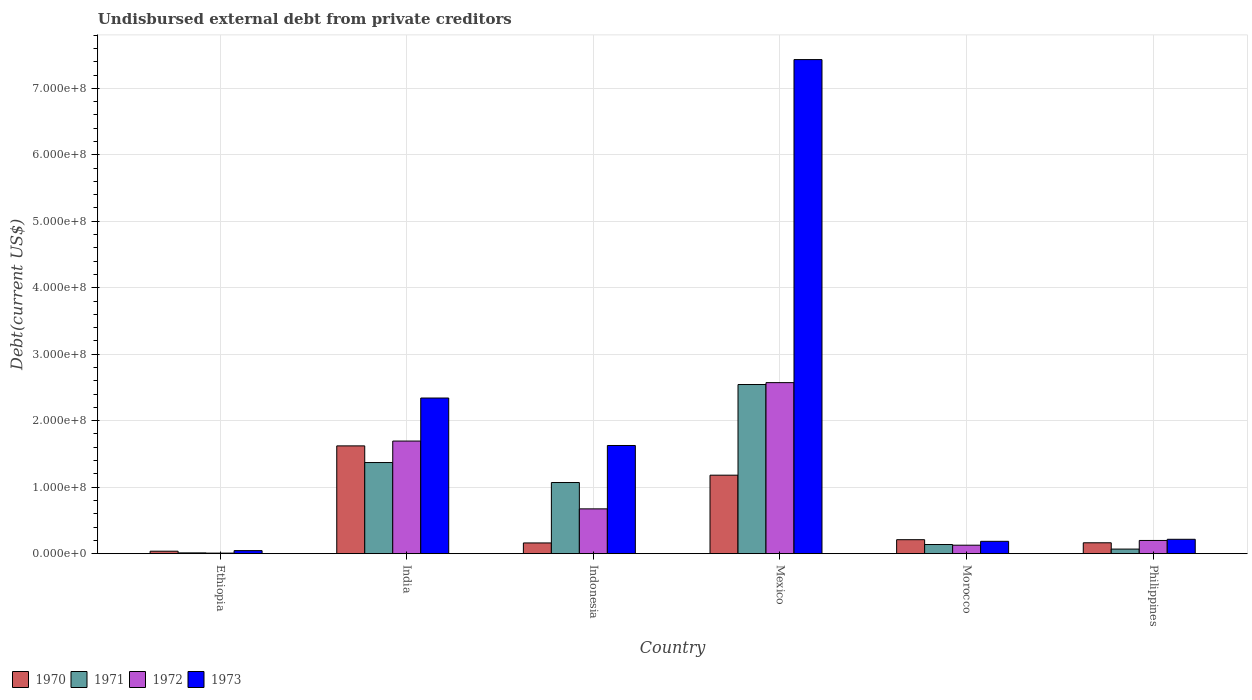How many different coloured bars are there?
Offer a terse response. 4. Are the number of bars per tick equal to the number of legend labels?
Your answer should be very brief. Yes. Are the number of bars on each tick of the X-axis equal?
Your answer should be compact. Yes. How many bars are there on the 2nd tick from the left?
Give a very brief answer. 4. What is the label of the 3rd group of bars from the left?
Keep it short and to the point. Indonesia. What is the total debt in 1972 in Mexico?
Offer a very short reply. 2.57e+08. Across all countries, what is the maximum total debt in 1971?
Offer a terse response. 2.54e+08. Across all countries, what is the minimum total debt in 1971?
Make the answer very short. 1.16e+06. In which country was the total debt in 1973 minimum?
Your response must be concise. Ethiopia. What is the total total debt in 1971 in the graph?
Make the answer very short. 5.20e+08. What is the difference between the total debt in 1973 in Ethiopia and that in Indonesia?
Offer a very short reply. -1.58e+08. What is the difference between the total debt in 1972 in Morocco and the total debt in 1973 in India?
Ensure brevity in your answer.  -2.21e+08. What is the average total debt in 1972 per country?
Provide a short and direct response. 8.79e+07. What is the difference between the total debt of/in 1972 and total debt of/in 1971 in Morocco?
Provide a succinct answer. -1.01e+06. In how many countries, is the total debt in 1972 greater than 420000000 US$?
Provide a short and direct response. 0. What is the ratio of the total debt in 1973 in Indonesia to that in Morocco?
Ensure brevity in your answer.  8.77. Is the total debt in 1970 in Ethiopia less than that in Indonesia?
Ensure brevity in your answer.  Yes. What is the difference between the highest and the second highest total debt in 1971?
Make the answer very short. 1.47e+08. What is the difference between the highest and the lowest total debt in 1971?
Ensure brevity in your answer.  2.53e+08. In how many countries, is the total debt in 1970 greater than the average total debt in 1970 taken over all countries?
Provide a succinct answer. 2. Is the sum of the total debt in 1970 in Ethiopia and India greater than the maximum total debt in 1971 across all countries?
Ensure brevity in your answer.  No. What does the 4th bar from the right in Philippines represents?
Give a very brief answer. 1970. Is it the case that in every country, the sum of the total debt in 1972 and total debt in 1970 is greater than the total debt in 1973?
Offer a terse response. No. Are all the bars in the graph horizontal?
Provide a succinct answer. No. How many countries are there in the graph?
Offer a very short reply. 6. What is the difference between two consecutive major ticks on the Y-axis?
Give a very brief answer. 1.00e+08. Does the graph contain grids?
Keep it short and to the point. Yes. How many legend labels are there?
Make the answer very short. 4. What is the title of the graph?
Your response must be concise. Undisbursed external debt from private creditors. What is the label or title of the Y-axis?
Offer a very short reply. Debt(current US$). What is the Debt(current US$) in 1970 in Ethiopia?
Provide a succinct answer. 3.70e+06. What is the Debt(current US$) in 1971 in Ethiopia?
Your answer should be compact. 1.16e+06. What is the Debt(current US$) in 1972 in Ethiopia?
Your response must be concise. 8.20e+05. What is the Debt(current US$) in 1973 in Ethiopia?
Your response must be concise. 4.57e+06. What is the Debt(current US$) of 1970 in India?
Your answer should be compact. 1.62e+08. What is the Debt(current US$) in 1971 in India?
Offer a terse response. 1.37e+08. What is the Debt(current US$) of 1972 in India?
Your response must be concise. 1.69e+08. What is the Debt(current US$) in 1973 in India?
Your response must be concise. 2.34e+08. What is the Debt(current US$) of 1970 in Indonesia?
Your answer should be very brief. 1.61e+07. What is the Debt(current US$) in 1971 in Indonesia?
Your response must be concise. 1.07e+08. What is the Debt(current US$) in 1972 in Indonesia?
Keep it short and to the point. 6.74e+07. What is the Debt(current US$) of 1973 in Indonesia?
Ensure brevity in your answer.  1.63e+08. What is the Debt(current US$) in 1970 in Mexico?
Give a very brief answer. 1.18e+08. What is the Debt(current US$) in 1971 in Mexico?
Your response must be concise. 2.54e+08. What is the Debt(current US$) in 1972 in Mexico?
Your answer should be very brief. 2.57e+08. What is the Debt(current US$) of 1973 in Mexico?
Provide a short and direct response. 7.43e+08. What is the Debt(current US$) in 1970 in Morocco?
Your answer should be very brief. 2.10e+07. What is the Debt(current US$) in 1971 in Morocco?
Offer a very short reply. 1.37e+07. What is the Debt(current US$) in 1972 in Morocco?
Offer a terse response. 1.27e+07. What is the Debt(current US$) in 1973 in Morocco?
Your response must be concise. 1.86e+07. What is the Debt(current US$) in 1970 in Philippines?
Make the answer very short. 1.64e+07. What is the Debt(current US$) in 1971 in Philippines?
Provide a short and direct response. 6.87e+06. What is the Debt(current US$) of 1972 in Philippines?
Your answer should be very brief. 1.99e+07. What is the Debt(current US$) in 1973 in Philippines?
Provide a short and direct response. 2.16e+07. Across all countries, what is the maximum Debt(current US$) of 1970?
Make the answer very short. 1.62e+08. Across all countries, what is the maximum Debt(current US$) of 1971?
Give a very brief answer. 2.54e+08. Across all countries, what is the maximum Debt(current US$) in 1972?
Your response must be concise. 2.57e+08. Across all countries, what is the maximum Debt(current US$) in 1973?
Offer a terse response. 7.43e+08. Across all countries, what is the minimum Debt(current US$) in 1970?
Your answer should be compact. 3.70e+06. Across all countries, what is the minimum Debt(current US$) in 1971?
Give a very brief answer. 1.16e+06. Across all countries, what is the minimum Debt(current US$) of 1972?
Provide a short and direct response. 8.20e+05. Across all countries, what is the minimum Debt(current US$) of 1973?
Give a very brief answer. 4.57e+06. What is the total Debt(current US$) of 1970 in the graph?
Make the answer very short. 3.37e+08. What is the total Debt(current US$) in 1971 in the graph?
Provide a short and direct response. 5.20e+08. What is the total Debt(current US$) in 1972 in the graph?
Your answer should be very brief. 5.27e+08. What is the total Debt(current US$) in 1973 in the graph?
Offer a terse response. 1.18e+09. What is the difference between the Debt(current US$) in 1970 in Ethiopia and that in India?
Keep it short and to the point. -1.58e+08. What is the difference between the Debt(current US$) of 1971 in Ethiopia and that in India?
Keep it short and to the point. -1.36e+08. What is the difference between the Debt(current US$) in 1972 in Ethiopia and that in India?
Give a very brief answer. -1.69e+08. What is the difference between the Debt(current US$) in 1973 in Ethiopia and that in India?
Make the answer very short. -2.30e+08. What is the difference between the Debt(current US$) of 1970 in Ethiopia and that in Indonesia?
Offer a terse response. -1.24e+07. What is the difference between the Debt(current US$) of 1971 in Ethiopia and that in Indonesia?
Your response must be concise. -1.06e+08. What is the difference between the Debt(current US$) of 1972 in Ethiopia and that in Indonesia?
Provide a succinct answer. -6.66e+07. What is the difference between the Debt(current US$) in 1973 in Ethiopia and that in Indonesia?
Keep it short and to the point. -1.58e+08. What is the difference between the Debt(current US$) in 1970 in Ethiopia and that in Mexico?
Your answer should be very brief. -1.14e+08. What is the difference between the Debt(current US$) of 1971 in Ethiopia and that in Mexico?
Give a very brief answer. -2.53e+08. What is the difference between the Debt(current US$) in 1972 in Ethiopia and that in Mexico?
Ensure brevity in your answer.  -2.56e+08. What is the difference between the Debt(current US$) in 1973 in Ethiopia and that in Mexico?
Your answer should be compact. -7.39e+08. What is the difference between the Debt(current US$) in 1970 in Ethiopia and that in Morocco?
Ensure brevity in your answer.  -1.73e+07. What is the difference between the Debt(current US$) in 1971 in Ethiopia and that in Morocco?
Ensure brevity in your answer.  -1.26e+07. What is the difference between the Debt(current US$) in 1972 in Ethiopia and that in Morocco?
Keep it short and to the point. -1.19e+07. What is the difference between the Debt(current US$) of 1973 in Ethiopia and that in Morocco?
Your answer should be very brief. -1.40e+07. What is the difference between the Debt(current US$) of 1970 in Ethiopia and that in Philippines?
Keep it short and to the point. -1.27e+07. What is the difference between the Debt(current US$) of 1971 in Ethiopia and that in Philippines?
Your answer should be very brief. -5.71e+06. What is the difference between the Debt(current US$) of 1972 in Ethiopia and that in Philippines?
Offer a terse response. -1.90e+07. What is the difference between the Debt(current US$) of 1973 in Ethiopia and that in Philippines?
Give a very brief answer. -1.71e+07. What is the difference between the Debt(current US$) of 1970 in India and that in Indonesia?
Offer a very short reply. 1.46e+08. What is the difference between the Debt(current US$) of 1971 in India and that in Indonesia?
Provide a short and direct response. 3.00e+07. What is the difference between the Debt(current US$) of 1972 in India and that in Indonesia?
Keep it short and to the point. 1.02e+08. What is the difference between the Debt(current US$) in 1973 in India and that in Indonesia?
Make the answer very short. 7.14e+07. What is the difference between the Debt(current US$) of 1970 in India and that in Mexico?
Keep it short and to the point. 4.41e+07. What is the difference between the Debt(current US$) in 1971 in India and that in Mexico?
Offer a very short reply. -1.17e+08. What is the difference between the Debt(current US$) of 1972 in India and that in Mexico?
Keep it short and to the point. -8.79e+07. What is the difference between the Debt(current US$) in 1973 in India and that in Mexico?
Your response must be concise. -5.09e+08. What is the difference between the Debt(current US$) in 1970 in India and that in Morocco?
Provide a short and direct response. 1.41e+08. What is the difference between the Debt(current US$) of 1971 in India and that in Morocco?
Give a very brief answer. 1.23e+08. What is the difference between the Debt(current US$) in 1972 in India and that in Morocco?
Your response must be concise. 1.57e+08. What is the difference between the Debt(current US$) in 1973 in India and that in Morocco?
Ensure brevity in your answer.  2.16e+08. What is the difference between the Debt(current US$) of 1970 in India and that in Philippines?
Keep it short and to the point. 1.46e+08. What is the difference between the Debt(current US$) of 1971 in India and that in Philippines?
Your response must be concise. 1.30e+08. What is the difference between the Debt(current US$) in 1972 in India and that in Philippines?
Ensure brevity in your answer.  1.50e+08. What is the difference between the Debt(current US$) in 1973 in India and that in Philippines?
Ensure brevity in your answer.  2.12e+08. What is the difference between the Debt(current US$) in 1970 in Indonesia and that in Mexico?
Offer a terse response. -1.02e+08. What is the difference between the Debt(current US$) in 1971 in Indonesia and that in Mexico?
Give a very brief answer. -1.47e+08. What is the difference between the Debt(current US$) of 1972 in Indonesia and that in Mexico?
Provide a succinct answer. -1.90e+08. What is the difference between the Debt(current US$) in 1973 in Indonesia and that in Mexico?
Provide a succinct answer. -5.81e+08. What is the difference between the Debt(current US$) in 1970 in Indonesia and that in Morocco?
Provide a short and direct response. -4.89e+06. What is the difference between the Debt(current US$) of 1971 in Indonesia and that in Morocco?
Keep it short and to the point. 9.33e+07. What is the difference between the Debt(current US$) of 1972 in Indonesia and that in Morocco?
Offer a terse response. 5.46e+07. What is the difference between the Debt(current US$) in 1973 in Indonesia and that in Morocco?
Your answer should be very brief. 1.44e+08. What is the difference between the Debt(current US$) of 1970 in Indonesia and that in Philippines?
Keep it short and to the point. -2.28e+05. What is the difference between the Debt(current US$) of 1971 in Indonesia and that in Philippines?
Keep it short and to the point. 1.00e+08. What is the difference between the Debt(current US$) of 1972 in Indonesia and that in Philippines?
Your answer should be compact. 4.75e+07. What is the difference between the Debt(current US$) of 1973 in Indonesia and that in Philippines?
Keep it short and to the point. 1.41e+08. What is the difference between the Debt(current US$) in 1970 in Mexico and that in Morocco?
Make the answer very short. 9.70e+07. What is the difference between the Debt(current US$) of 1971 in Mexico and that in Morocco?
Make the answer very short. 2.41e+08. What is the difference between the Debt(current US$) in 1972 in Mexico and that in Morocco?
Make the answer very short. 2.45e+08. What is the difference between the Debt(current US$) in 1973 in Mexico and that in Morocco?
Your response must be concise. 7.25e+08. What is the difference between the Debt(current US$) of 1970 in Mexico and that in Philippines?
Offer a terse response. 1.02e+08. What is the difference between the Debt(current US$) in 1971 in Mexico and that in Philippines?
Give a very brief answer. 2.48e+08. What is the difference between the Debt(current US$) of 1972 in Mexico and that in Philippines?
Keep it short and to the point. 2.37e+08. What is the difference between the Debt(current US$) of 1973 in Mexico and that in Philippines?
Make the answer very short. 7.22e+08. What is the difference between the Debt(current US$) in 1970 in Morocco and that in Philippines?
Keep it short and to the point. 4.66e+06. What is the difference between the Debt(current US$) in 1971 in Morocco and that in Philippines?
Make the answer very short. 6.88e+06. What is the difference between the Debt(current US$) in 1972 in Morocco and that in Philippines?
Give a very brief answer. -7.12e+06. What is the difference between the Debt(current US$) in 1973 in Morocco and that in Philippines?
Your answer should be very brief. -3.06e+06. What is the difference between the Debt(current US$) of 1970 in Ethiopia and the Debt(current US$) of 1971 in India?
Give a very brief answer. -1.33e+08. What is the difference between the Debt(current US$) in 1970 in Ethiopia and the Debt(current US$) in 1972 in India?
Give a very brief answer. -1.66e+08. What is the difference between the Debt(current US$) in 1970 in Ethiopia and the Debt(current US$) in 1973 in India?
Offer a very short reply. -2.30e+08. What is the difference between the Debt(current US$) of 1971 in Ethiopia and the Debt(current US$) of 1972 in India?
Ensure brevity in your answer.  -1.68e+08. What is the difference between the Debt(current US$) of 1971 in Ethiopia and the Debt(current US$) of 1973 in India?
Give a very brief answer. -2.33e+08. What is the difference between the Debt(current US$) of 1972 in Ethiopia and the Debt(current US$) of 1973 in India?
Your answer should be very brief. -2.33e+08. What is the difference between the Debt(current US$) of 1970 in Ethiopia and the Debt(current US$) of 1971 in Indonesia?
Offer a very short reply. -1.03e+08. What is the difference between the Debt(current US$) in 1970 in Ethiopia and the Debt(current US$) in 1972 in Indonesia?
Your answer should be compact. -6.37e+07. What is the difference between the Debt(current US$) of 1970 in Ethiopia and the Debt(current US$) of 1973 in Indonesia?
Give a very brief answer. -1.59e+08. What is the difference between the Debt(current US$) in 1971 in Ethiopia and the Debt(current US$) in 1972 in Indonesia?
Make the answer very short. -6.62e+07. What is the difference between the Debt(current US$) of 1971 in Ethiopia and the Debt(current US$) of 1973 in Indonesia?
Keep it short and to the point. -1.62e+08. What is the difference between the Debt(current US$) in 1972 in Ethiopia and the Debt(current US$) in 1973 in Indonesia?
Make the answer very short. -1.62e+08. What is the difference between the Debt(current US$) in 1970 in Ethiopia and the Debt(current US$) in 1971 in Mexico?
Ensure brevity in your answer.  -2.51e+08. What is the difference between the Debt(current US$) in 1970 in Ethiopia and the Debt(current US$) in 1972 in Mexico?
Give a very brief answer. -2.54e+08. What is the difference between the Debt(current US$) in 1970 in Ethiopia and the Debt(current US$) in 1973 in Mexico?
Provide a short and direct response. -7.40e+08. What is the difference between the Debt(current US$) in 1971 in Ethiopia and the Debt(current US$) in 1972 in Mexico?
Provide a short and direct response. -2.56e+08. What is the difference between the Debt(current US$) of 1971 in Ethiopia and the Debt(current US$) of 1973 in Mexico?
Your answer should be very brief. -7.42e+08. What is the difference between the Debt(current US$) of 1972 in Ethiopia and the Debt(current US$) of 1973 in Mexico?
Your answer should be very brief. -7.42e+08. What is the difference between the Debt(current US$) in 1970 in Ethiopia and the Debt(current US$) in 1971 in Morocco?
Provide a succinct answer. -1.01e+07. What is the difference between the Debt(current US$) in 1970 in Ethiopia and the Debt(current US$) in 1972 in Morocco?
Your response must be concise. -9.04e+06. What is the difference between the Debt(current US$) of 1970 in Ethiopia and the Debt(current US$) of 1973 in Morocco?
Offer a very short reply. -1.49e+07. What is the difference between the Debt(current US$) in 1971 in Ethiopia and the Debt(current US$) in 1972 in Morocco?
Your answer should be very brief. -1.16e+07. What is the difference between the Debt(current US$) of 1971 in Ethiopia and the Debt(current US$) of 1973 in Morocco?
Make the answer very short. -1.74e+07. What is the difference between the Debt(current US$) of 1972 in Ethiopia and the Debt(current US$) of 1973 in Morocco?
Offer a very short reply. -1.77e+07. What is the difference between the Debt(current US$) of 1970 in Ethiopia and the Debt(current US$) of 1971 in Philippines?
Offer a terse response. -3.18e+06. What is the difference between the Debt(current US$) in 1970 in Ethiopia and the Debt(current US$) in 1972 in Philippines?
Offer a terse response. -1.62e+07. What is the difference between the Debt(current US$) of 1970 in Ethiopia and the Debt(current US$) of 1973 in Philippines?
Keep it short and to the point. -1.79e+07. What is the difference between the Debt(current US$) in 1971 in Ethiopia and the Debt(current US$) in 1972 in Philippines?
Your answer should be compact. -1.87e+07. What is the difference between the Debt(current US$) of 1971 in Ethiopia and the Debt(current US$) of 1973 in Philippines?
Your response must be concise. -2.05e+07. What is the difference between the Debt(current US$) of 1972 in Ethiopia and the Debt(current US$) of 1973 in Philippines?
Give a very brief answer. -2.08e+07. What is the difference between the Debt(current US$) of 1970 in India and the Debt(current US$) of 1971 in Indonesia?
Provide a short and direct response. 5.51e+07. What is the difference between the Debt(current US$) of 1970 in India and the Debt(current US$) of 1972 in Indonesia?
Ensure brevity in your answer.  9.47e+07. What is the difference between the Debt(current US$) in 1970 in India and the Debt(current US$) in 1973 in Indonesia?
Your answer should be compact. -5.84e+05. What is the difference between the Debt(current US$) of 1971 in India and the Debt(current US$) of 1972 in Indonesia?
Offer a very short reply. 6.97e+07. What is the difference between the Debt(current US$) of 1971 in India and the Debt(current US$) of 1973 in Indonesia?
Keep it short and to the point. -2.56e+07. What is the difference between the Debt(current US$) of 1972 in India and the Debt(current US$) of 1973 in Indonesia?
Make the answer very short. 6.68e+06. What is the difference between the Debt(current US$) of 1970 in India and the Debt(current US$) of 1971 in Mexico?
Offer a terse response. -9.23e+07. What is the difference between the Debt(current US$) in 1970 in India and the Debt(current US$) in 1972 in Mexico?
Offer a terse response. -9.51e+07. What is the difference between the Debt(current US$) of 1970 in India and the Debt(current US$) of 1973 in Mexico?
Provide a succinct answer. -5.81e+08. What is the difference between the Debt(current US$) in 1971 in India and the Debt(current US$) in 1972 in Mexico?
Offer a very short reply. -1.20e+08. What is the difference between the Debt(current US$) in 1971 in India and the Debt(current US$) in 1973 in Mexico?
Your answer should be compact. -6.06e+08. What is the difference between the Debt(current US$) of 1972 in India and the Debt(current US$) of 1973 in Mexico?
Keep it short and to the point. -5.74e+08. What is the difference between the Debt(current US$) of 1970 in India and the Debt(current US$) of 1971 in Morocco?
Give a very brief answer. 1.48e+08. What is the difference between the Debt(current US$) of 1970 in India and the Debt(current US$) of 1972 in Morocco?
Offer a very short reply. 1.49e+08. What is the difference between the Debt(current US$) in 1970 in India and the Debt(current US$) in 1973 in Morocco?
Provide a short and direct response. 1.44e+08. What is the difference between the Debt(current US$) of 1971 in India and the Debt(current US$) of 1972 in Morocco?
Ensure brevity in your answer.  1.24e+08. What is the difference between the Debt(current US$) of 1971 in India and the Debt(current US$) of 1973 in Morocco?
Offer a very short reply. 1.19e+08. What is the difference between the Debt(current US$) in 1972 in India and the Debt(current US$) in 1973 in Morocco?
Offer a terse response. 1.51e+08. What is the difference between the Debt(current US$) in 1970 in India and the Debt(current US$) in 1971 in Philippines?
Your answer should be very brief. 1.55e+08. What is the difference between the Debt(current US$) of 1970 in India and the Debt(current US$) of 1972 in Philippines?
Ensure brevity in your answer.  1.42e+08. What is the difference between the Debt(current US$) of 1970 in India and the Debt(current US$) of 1973 in Philippines?
Make the answer very short. 1.41e+08. What is the difference between the Debt(current US$) in 1971 in India and the Debt(current US$) in 1972 in Philippines?
Offer a very short reply. 1.17e+08. What is the difference between the Debt(current US$) in 1971 in India and the Debt(current US$) in 1973 in Philippines?
Your answer should be very brief. 1.15e+08. What is the difference between the Debt(current US$) in 1972 in India and the Debt(current US$) in 1973 in Philippines?
Your response must be concise. 1.48e+08. What is the difference between the Debt(current US$) in 1970 in Indonesia and the Debt(current US$) in 1971 in Mexico?
Make the answer very short. -2.38e+08. What is the difference between the Debt(current US$) in 1970 in Indonesia and the Debt(current US$) in 1972 in Mexico?
Make the answer very short. -2.41e+08. What is the difference between the Debt(current US$) of 1970 in Indonesia and the Debt(current US$) of 1973 in Mexico?
Your response must be concise. -7.27e+08. What is the difference between the Debt(current US$) in 1971 in Indonesia and the Debt(current US$) in 1972 in Mexico?
Provide a succinct answer. -1.50e+08. What is the difference between the Debt(current US$) in 1971 in Indonesia and the Debt(current US$) in 1973 in Mexico?
Your answer should be very brief. -6.36e+08. What is the difference between the Debt(current US$) of 1972 in Indonesia and the Debt(current US$) of 1973 in Mexico?
Provide a succinct answer. -6.76e+08. What is the difference between the Debt(current US$) in 1970 in Indonesia and the Debt(current US$) in 1971 in Morocco?
Your answer should be very brief. 2.38e+06. What is the difference between the Debt(current US$) in 1970 in Indonesia and the Debt(current US$) in 1972 in Morocco?
Offer a terse response. 3.39e+06. What is the difference between the Debt(current US$) in 1970 in Indonesia and the Debt(current US$) in 1973 in Morocco?
Ensure brevity in your answer.  -2.44e+06. What is the difference between the Debt(current US$) of 1971 in Indonesia and the Debt(current US$) of 1972 in Morocco?
Give a very brief answer. 9.43e+07. What is the difference between the Debt(current US$) in 1971 in Indonesia and the Debt(current US$) in 1973 in Morocco?
Provide a succinct answer. 8.85e+07. What is the difference between the Debt(current US$) of 1972 in Indonesia and the Debt(current US$) of 1973 in Morocco?
Provide a short and direct response. 4.88e+07. What is the difference between the Debt(current US$) of 1970 in Indonesia and the Debt(current US$) of 1971 in Philippines?
Provide a succinct answer. 9.25e+06. What is the difference between the Debt(current US$) in 1970 in Indonesia and the Debt(current US$) in 1972 in Philippines?
Offer a very short reply. -3.73e+06. What is the difference between the Debt(current US$) in 1970 in Indonesia and the Debt(current US$) in 1973 in Philippines?
Your answer should be very brief. -5.49e+06. What is the difference between the Debt(current US$) of 1971 in Indonesia and the Debt(current US$) of 1972 in Philippines?
Provide a succinct answer. 8.72e+07. What is the difference between the Debt(current US$) of 1971 in Indonesia and the Debt(current US$) of 1973 in Philippines?
Your answer should be compact. 8.54e+07. What is the difference between the Debt(current US$) in 1972 in Indonesia and the Debt(current US$) in 1973 in Philippines?
Your answer should be very brief. 4.58e+07. What is the difference between the Debt(current US$) in 1970 in Mexico and the Debt(current US$) in 1971 in Morocco?
Your answer should be very brief. 1.04e+08. What is the difference between the Debt(current US$) in 1970 in Mexico and the Debt(current US$) in 1972 in Morocco?
Your response must be concise. 1.05e+08. What is the difference between the Debt(current US$) in 1970 in Mexico and the Debt(current US$) in 1973 in Morocco?
Provide a short and direct response. 9.95e+07. What is the difference between the Debt(current US$) in 1971 in Mexico and the Debt(current US$) in 1972 in Morocco?
Make the answer very short. 2.42e+08. What is the difference between the Debt(current US$) in 1971 in Mexico and the Debt(current US$) in 1973 in Morocco?
Give a very brief answer. 2.36e+08. What is the difference between the Debt(current US$) in 1972 in Mexico and the Debt(current US$) in 1973 in Morocco?
Your response must be concise. 2.39e+08. What is the difference between the Debt(current US$) of 1970 in Mexico and the Debt(current US$) of 1971 in Philippines?
Your response must be concise. 1.11e+08. What is the difference between the Debt(current US$) in 1970 in Mexico and the Debt(current US$) in 1972 in Philippines?
Keep it short and to the point. 9.82e+07. What is the difference between the Debt(current US$) in 1970 in Mexico and the Debt(current US$) in 1973 in Philippines?
Make the answer very short. 9.64e+07. What is the difference between the Debt(current US$) of 1971 in Mexico and the Debt(current US$) of 1972 in Philippines?
Provide a short and direct response. 2.35e+08. What is the difference between the Debt(current US$) in 1971 in Mexico and the Debt(current US$) in 1973 in Philippines?
Provide a short and direct response. 2.33e+08. What is the difference between the Debt(current US$) of 1972 in Mexico and the Debt(current US$) of 1973 in Philippines?
Provide a succinct answer. 2.36e+08. What is the difference between the Debt(current US$) of 1970 in Morocco and the Debt(current US$) of 1971 in Philippines?
Ensure brevity in your answer.  1.41e+07. What is the difference between the Debt(current US$) of 1970 in Morocco and the Debt(current US$) of 1972 in Philippines?
Your answer should be very brief. 1.16e+06. What is the difference between the Debt(current US$) in 1970 in Morocco and the Debt(current US$) in 1973 in Philippines?
Make the answer very short. -6.03e+05. What is the difference between the Debt(current US$) in 1971 in Morocco and the Debt(current US$) in 1972 in Philippines?
Your response must be concise. -6.10e+06. What is the difference between the Debt(current US$) of 1971 in Morocco and the Debt(current US$) of 1973 in Philippines?
Offer a very short reply. -7.87e+06. What is the difference between the Debt(current US$) in 1972 in Morocco and the Debt(current US$) in 1973 in Philippines?
Offer a very short reply. -8.88e+06. What is the average Debt(current US$) of 1970 per country?
Your answer should be very brief. 5.62e+07. What is the average Debt(current US$) of 1971 per country?
Your answer should be compact. 8.67e+07. What is the average Debt(current US$) in 1972 per country?
Offer a terse response. 8.79e+07. What is the average Debt(current US$) in 1973 per country?
Keep it short and to the point. 1.97e+08. What is the difference between the Debt(current US$) in 1970 and Debt(current US$) in 1971 in Ethiopia?
Your response must be concise. 2.53e+06. What is the difference between the Debt(current US$) in 1970 and Debt(current US$) in 1972 in Ethiopia?
Your response must be concise. 2.88e+06. What is the difference between the Debt(current US$) of 1970 and Debt(current US$) of 1973 in Ethiopia?
Offer a very short reply. -8.70e+05. What is the difference between the Debt(current US$) of 1971 and Debt(current US$) of 1972 in Ethiopia?
Your response must be concise. 3.45e+05. What is the difference between the Debt(current US$) of 1971 and Debt(current US$) of 1973 in Ethiopia?
Provide a short and direct response. -3.40e+06. What is the difference between the Debt(current US$) in 1972 and Debt(current US$) in 1973 in Ethiopia?
Your answer should be very brief. -3.75e+06. What is the difference between the Debt(current US$) in 1970 and Debt(current US$) in 1971 in India?
Provide a short and direct response. 2.51e+07. What is the difference between the Debt(current US$) in 1970 and Debt(current US$) in 1972 in India?
Your response must be concise. -7.26e+06. What is the difference between the Debt(current US$) in 1970 and Debt(current US$) in 1973 in India?
Keep it short and to the point. -7.20e+07. What is the difference between the Debt(current US$) in 1971 and Debt(current US$) in 1972 in India?
Your answer should be compact. -3.23e+07. What is the difference between the Debt(current US$) in 1971 and Debt(current US$) in 1973 in India?
Provide a succinct answer. -9.70e+07. What is the difference between the Debt(current US$) of 1972 and Debt(current US$) of 1973 in India?
Give a very brief answer. -6.47e+07. What is the difference between the Debt(current US$) of 1970 and Debt(current US$) of 1971 in Indonesia?
Offer a very short reply. -9.09e+07. What is the difference between the Debt(current US$) of 1970 and Debt(current US$) of 1972 in Indonesia?
Offer a very short reply. -5.12e+07. What is the difference between the Debt(current US$) in 1970 and Debt(current US$) in 1973 in Indonesia?
Offer a very short reply. -1.47e+08. What is the difference between the Debt(current US$) in 1971 and Debt(current US$) in 1972 in Indonesia?
Provide a succinct answer. 3.96e+07. What is the difference between the Debt(current US$) of 1971 and Debt(current US$) of 1973 in Indonesia?
Your response must be concise. -5.57e+07. What is the difference between the Debt(current US$) in 1972 and Debt(current US$) in 1973 in Indonesia?
Your answer should be compact. -9.53e+07. What is the difference between the Debt(current US$) of 1970 and Debt(current US$) of 1971 in Mexico?
Offer a very short reply. -1.36e+08. What is the difference between the Debt(current US$) of 1970 and Debt(current US$) of 1972 in Mexico?
Give a very brief answer. -1.39e+08. What is the difference between the Debt(current US$) of 1970 and Debt(current US$) of 1973 in Mexico?
Your answer should be compact. -6.25e+08. What is the difference between the Debt(current US$) of 1971 and Debt(current US$) of 1972 in Mexico?
Give a very brief answer. -2.84e+06. What is the difference between the Debt(current US$) of 1971 and Debt(current US$) of 1973 in Mexico?
Your response must be concise. -4.89e+08. What is the difference between the Debt(current US$) of 1972 and Debt(current US$) of 1973 in Mexico?
Ensure brevity in your answer.  -4.86e+08. What is the difference between the Debt(current US$) in 1970 and Debt(current US$) in 1971 in Morocco?
Offer a very short reply. 7.27e+06. What is the difference between the Debt(current US$) in 1970 and Debt(current US$) in 1972 in Morocco?
Your response must be concise. 8.28e+06. What is the difference between the Debt(current US$) of 1970 and Debt(current US$) of 1973 in Morocco?
Your response must be concise. 2.45e+06. What is the difference between the Debt(current US$) of 1971 and Debt(current US$) of 1972 in Morocco?
Provide a succinct answer. 1.01e+06. What is the difference between the Debt(current US$) in 1971 and Debt(current US$) in 1973 in Morocco?
Give a very brief answer. -4.81e+06. What is the difference between the Debt(current US$) in 1972 and Debt(current US$) in 1973 in Morocco?
Provide a succinct answer. -5.82e+06. What is the difference between the Debt(current US$) in 1970 and Debt(current US$) in 1971 in Philippines?
Offer a very short reply. 9.48e+06. What is the difference between the Debt(current US$) of 1970 and Debt(current US$) of 1972 in Philippines?
Make the answer very short. -3.50e+06. What is the difference between the Debt(current US$) in 1970 and Debt(current US$) in 1973 in Philippines?
Your answer should be compact. -5.27e+06. What is the difference between the Debt(current US$) in 1971 and Debt(current US$) in 1972 in Philippines?
Offer a terse response. -1.30e+07. What is the difference between the Debt(current US$) in 1971 and Debt(current US$) in 1973 in Philippines?
Keep it short and to the point. -1.47e+07. What is the difference between the Debt(current US$) in 1972 and Debt(current US$) in 1973 in Philippines?
Ensure brevity in your answer.  -1.76e+06. What is the ratio of the Debt(current US$) in 1970 in Ethiopia to that in India?
Give a very brief answer. 0.02. What is the ratio of the Debt(current US$) in 1971 in Ethiopia to that in India?
Provide a short and direct response. 0.01. What is the ratio of the Debt(current US$) in 1972 in Ethiopia to that in India?
Ensure brevity in your answer.  0. What is the ratio of the Debt(current US$) of 1973 in Ethiopia to that in India?
Your response must be concise. 0.02. What is the ratio of the Debt(current US$) in 1970 in Ethiopia to that in Indonesia?
Keep it short and to the point. 0.23. What is the ratio of the Debt(current US$) in 1971 in Ethiopia to that in Indonesia?
Ensure brevity in your answer.  0.01. What is the ratio of the Debt(current US$) in 1972 in Ethiopia to that in Indonesia?
Offer a very short reply. 0.01. What is the ratio of the Debt(current US$) in 1973 in Ethiopia to that in Indonesia?
Keep it short and to the point. 0.03. What is the ratio of the Debt(current US$) in 1970 in Ethiopia to that in Mexico?
Ensure brevity in your answer.  0.03. What is the ratio of the Debt(current US$) in 1971 in Ethiopia to that in Mexico?
Your response must be concise. 0. What is the ratio of the Debt(current US$) in 1972 in Ethiopia to that in Mexico?
Keep it short and to the point. 0. What is the ratio of the Debt(current US$) of 1973 in Ethiopia to that in Mexico?
Offer a very short reply. 0.01. What is the ratio of the Debt(current US$) of 1970 in Ethiopia to that in Morocco?
Offer a terse response. 0.18. What is the ratio of the Debt(current US$) of 1971 in Ethiopia to that in Morocco?
Provide a succinct answer. 0.08. What is the ratio of the Debt(current US$) in 1972 in Ethiopia to that in Morocco?
Your response must be concise. 0.06. What is the ratio of the Debt(current US$) in 1973 in Ethiopia to that in Morocco?
Offer a very short reply. 0.25. What is the ratio of the Debt(current US$) in 1970 in Ethiopia to that in Philippines?
Make the answer very short. 0.23. What is the ratio of the Debt(current US$) of 1971 in Ethiopia to that in Philippines?
Ensure brevity in your answer.  0.17. What is the ratio of the Debt(current US$) of 1972 in Ethiopia to that in Philippines?
Provide a short and direct response. 0.04. What is the ratio of the Debt(current US$) of 1973 in Ethiopia to that in Philippines?
Your response must be concise. 0.21. What is the ratio of the Debt(current US$) of 1970 in India to that in Indonesia?
Your answer should be very brief. 10.05. What is the ratio of the Debt(current US$) in 1971 in India to that in Indonesia?
Your answer should be very brief. 1.28. What is the ratio of the Debt(current US$) of 1972 in India to that in Indonesia?
Provide a succinct answer. 2.51. What is the ratio of the Debt(current US$) in 1973 in India to that in Indonesia?
Offer a terse response. 1.44. What is the ratio of the Debt(current US$) of 1970 in India to that in Mexico?
Give a very brief answer. 1.37. What is the ratio of the Debt(current US$) of 1971 in India to that in Mexico?
Provide a short and direct response. 0.54. What is the ratio of the Debt(current US$) in 1972 in India to that in Mexico?
Your answer should be compact. 0.66. What is the ratio of the Debt(current US$) of 1973 in India to that in Mexico?
Give a very brief answer. 0.32. What is the ratio of the Debt(current US$) of 1970 in India to that in Morocco?
Make the answer very short. 7.71. What is the ratio of the Debt(current US$) of 1971 in India to that in Morocco?
Give a very brief answer. 9.97. What is the ratio of the Debt(current US$) of 1972 in India to that in Morocco?
Your response must be concise. 13.3. What is the ratio of the Debt(current US$) in 1973 in India to that in Morocco?
Give a very brief answer. 12.61. What is the ratio of the Debt(current US$) in 1970 in India to that in Philippines?
Offer a very short reply. 9.91. What is the ratio of the Debt(current US$) in 1971 in India to that in Philippines?
Ensure brevity in your answer.  19.95. What is the ratio of the Debt(current US$) of 1972 in India to that in Philippines?
Your answer should be very brief. 8.53. What is the ratio of the Debt(current US$) in 1973 in India to that in Philippines?
Offer a very short reply. 10.83. What is the ratio of the Debt(current US$) in 1970 in Indonesia to that in Mexico?
Your answer should be compact. 0.14. What is the ratio of the Debt(current US$) of 1971 in Indonesia to that in Mexico?
Offer a terse response. 0.42. What is the ratio of the Debt(current US$) in 1972 in Indonesia to that in Mexico?
Provide a succinct answer. 0.26. What is the ratio of the Debt(current US$) of 1973 in Indonesia to that in Mexico?
Give a very brief answer. 0.22. What is the ratio of the Debt(current US$) in 1970 in Indonesia to that in Morocco?
Your answer should be compact. 0.77. What is the ratio of the Debt(current US$) of 1971 in Indonesia to that in Morocco?
Keep it short and to the point. 7.78. What is the ratio of the Debt(current US$) of 1972 in Indonesia to that in Morocco?
Make the answer very short. 5.29. What is the ratio of the Debt(current US$) in 1973 in Indonesia to that in Morocco?
Keep it short and to the point. 8.77. What is the ratio of the Debt(current US$) of 1970 in Indonesia to that in Philippines?
Keep it short and to the point. 0.99. What is the ratio of the Debt(current US$) in 1971 in Indonesia to that in Philippines?
Your response must be concise. 15.57. What is the ratio of the Debt(current US$) in 1972 in Indonesia to that in Philippines?
Offer a terse response. 3.39. What is the ratio of the Debt(current US$) of 1973 in Indonesia to that in Philippines?
Your answer should be very brief. 7.53. What is the ratio of the Debt(current US$) of 1970 in Mexico to that in Morocco?
Ensure brevity in your answer.  5.62. What is the ratio of the Debt(current US$) in 1971 in Mexico to that in Morocco?
Provide a short and direct response. 18.51. What is the ratio of the Debt(current US$) of 1972 in Mexico to that in Morocco?
Make the answer very short. 20.2. What is the ratio of the Debt(current US$) of 1973 in Mexico to that in Morocco?
Your answer should be compact. 40.04. What is the ratio of the Debt(current US$) of 1970 in Mexico to that in Philippines?
Your answer should be compact. 7.22. What is the ratio of the Debt(current US$) of 1971 in Mexico to that in Philippines?
Offer a very short reply. 37.02. What is the ratio of the Debt(current US$) in 1972 in Mexico to that in Philippines?
Give a very brief answer. 12.96. What is the ratio of the Debt(current US$) in 1973 in Mexico to that in Philippines?
Your response must be concise. 34.38. What is the ratio of the Debt(current US$) in 1970 in Morocco to that in Philippines?
Give a very brief answer. 1.29. What is the ratio of the Debt(current US$) of 1971 in Morocco to that in Philippines?
Provide a short and direct response. 2. What is the ratio of the Debt(current US$) of 1972 in Morocco to that in Philippines?
Your answer should be very brief. 0.64. What is the ratio of the Debt(current US$) in 1973 in Morocco to that in Philippines?
Keep it short and to the point. 0.86. What is the difference between the highest and the second highest Debt(current US$) of 1970?
Ensure brevity in your answer.  4.41e+07. What is the difference between the highest and the second highest Debt(current US$) of 1971?
Give a very brief answer. 1.17e+08. What is the difference between the highest and the second highest Debt(current US$) of 1972?
Make the answer very short. 8.79e+07. What is the difference between the highest and the second highest Debt(current US$) in 1973?
Your response must be concise. 5.09e+08. What is the difference between the highest and the lowest Debt(current US$) in 1970?
Keep it short and to the point. 1.58e+08. What is the difference between the highest and the lowest Debt(current US$) of 1971?
Offer a very short reply. 2.53e+08. What is the difference between the highest and the lowest Debt(current US$) in 1972?
Give a very brief answer. 2.56e+08. What is the difference between the highest and the lowest Debt(current US$) in 1973?
Provide a succinct answer. 7.39e+08. 